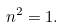<formula> <loc_0><loc_0><loc_500><loc_500>n ^ { 2 } = 1 .</formula> 